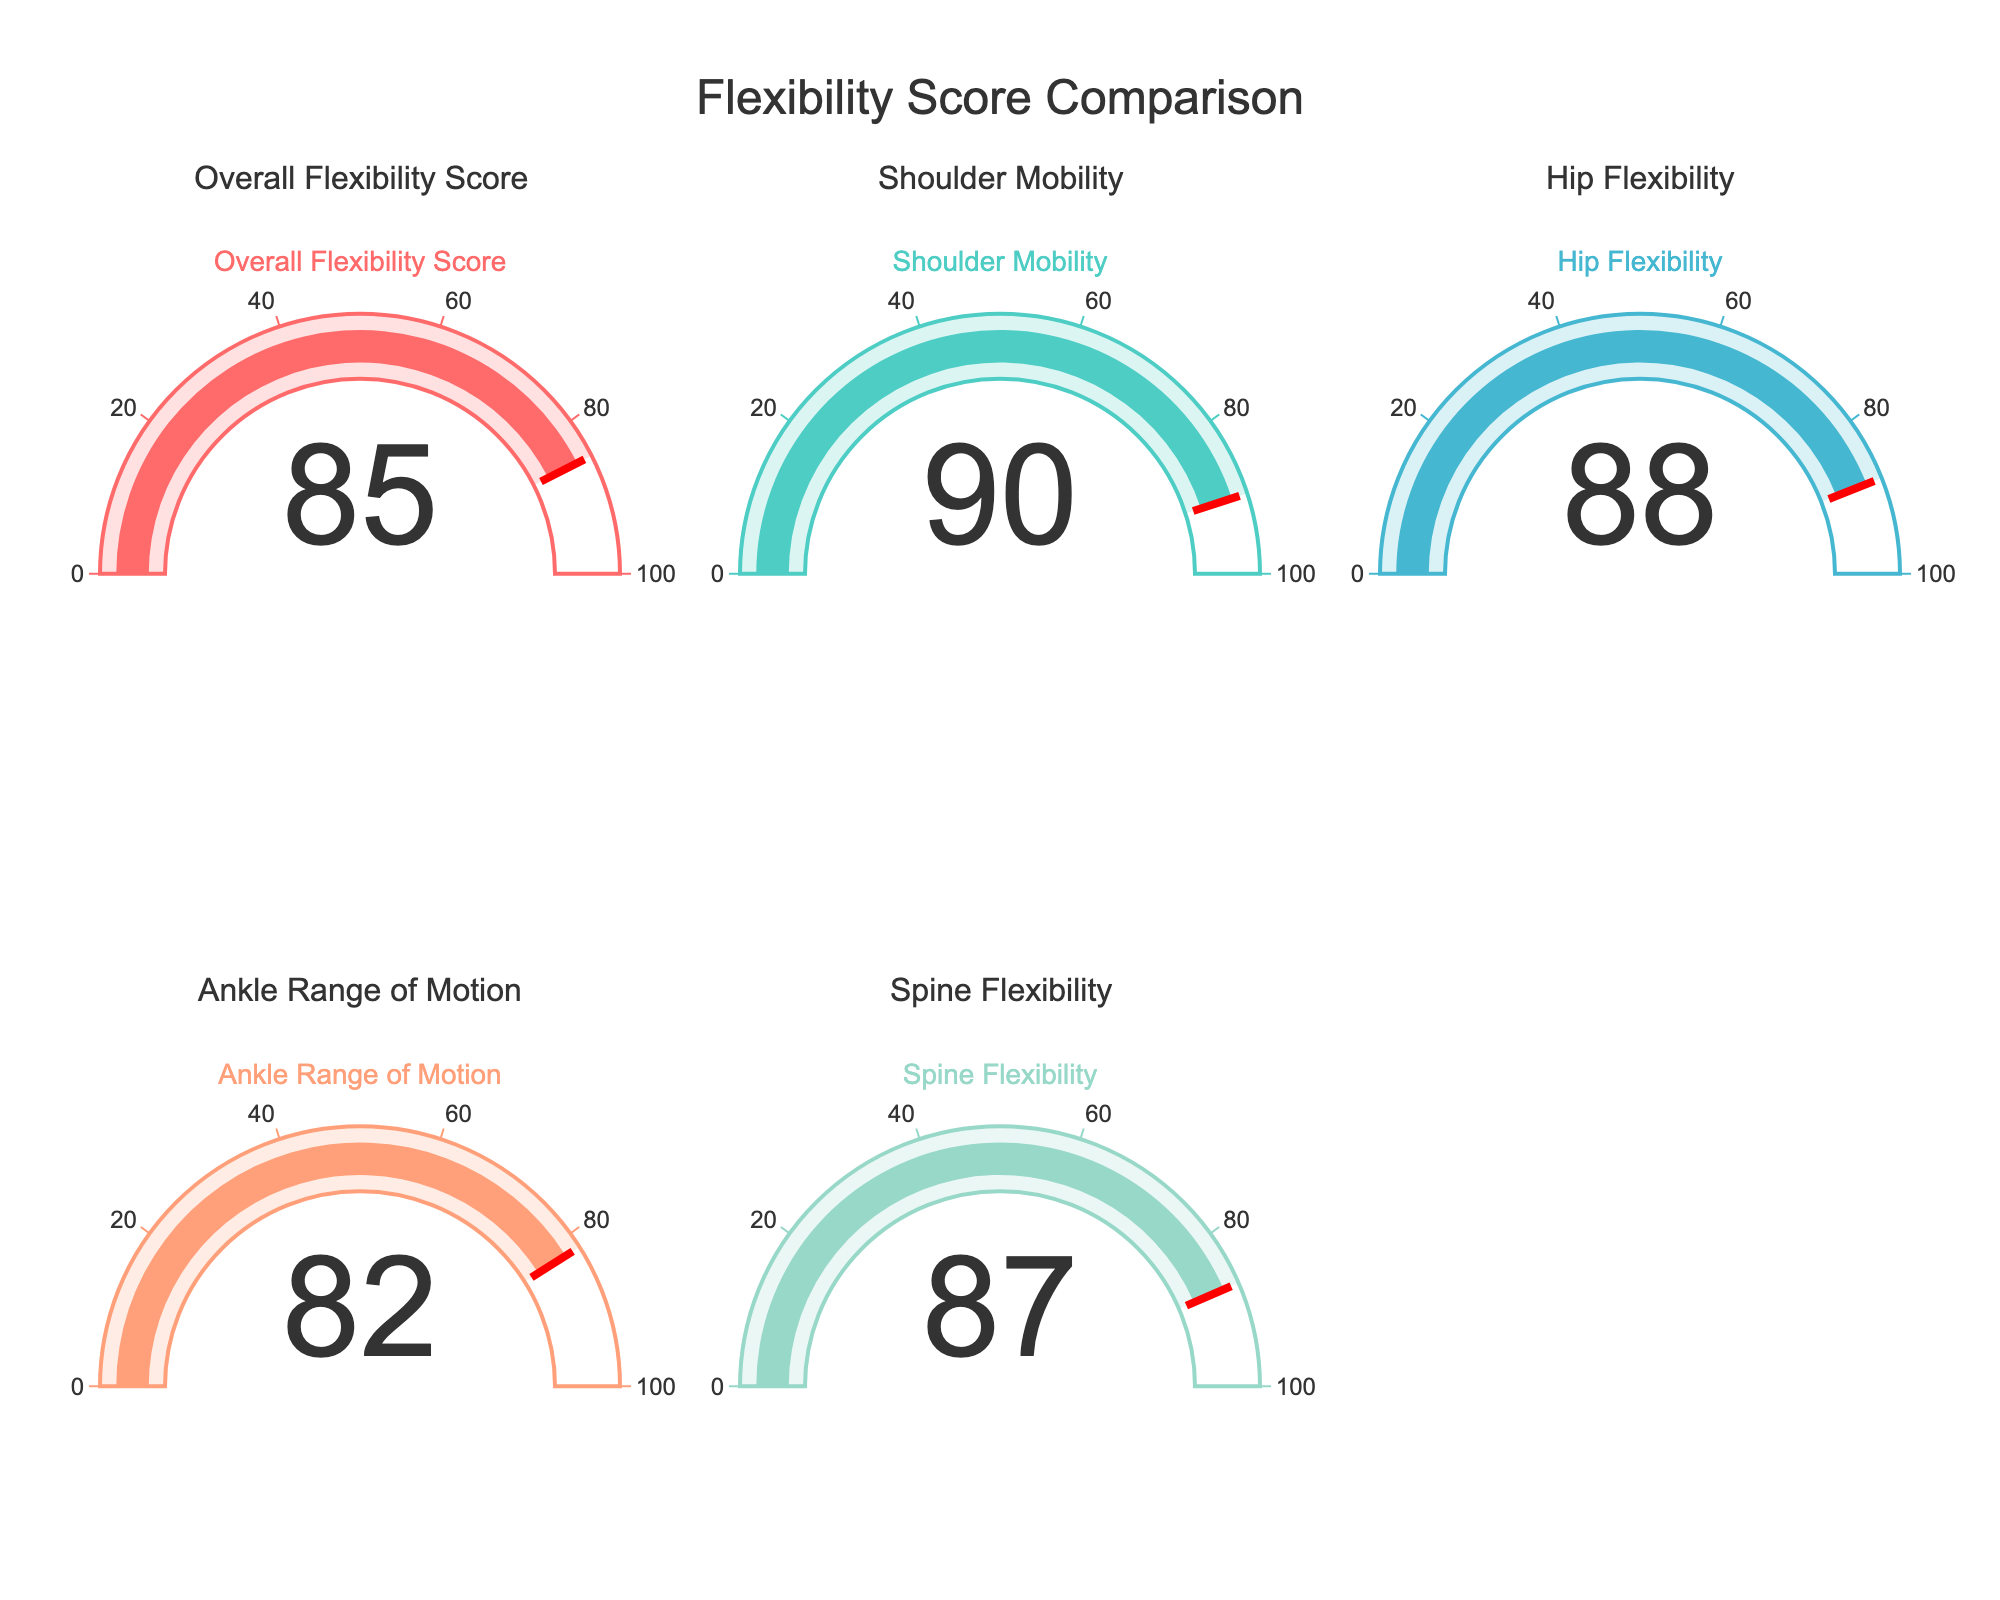What is the Overall Flexibility Score? The Indicator gauge for "Overall Flexibility Score" displays the numerical value directly, which is 85.
Answer: 85 What metric has the highest score? By looking at all the gauge charts, "Shoulder Mobility" has the highest value, which is 90.
Answer: Shoulder Mobility How much higher is the Shoulder Mobility score compared to the Ankle Range of Motion score? The Shoulder Mobility score is 90, and the Ankle Range of Motion score is 82. The difference is calculated as 90 - 82.
Answer: 8 Which metric has the lowest score, and what is that score? Among all the gauges, "Ankle Range of Motion" has the lowest score, which is 82.
Answer: Ankle Range of Motion, 82 What is the average of the overall scores displayed? Calculate the average of all the values: (85 + 90 + 88 + 82 + 87) / 5.
Answer: 86.4 Are any of the metrics below 85? Looking at the displayed values, "Ankle Range of Motion" is 82, which is below 85.
Answer: Yes How does Spine Flexibility compare to Hip Flexibility? The score for Spine Flexibility is 87, and the score for Hip Flexibility is 88. Therefore, Spine Flexibility is 1 point lower than Hip Flexibility.
Answer: 1 point lower What is the difference between the highest and lowest scores? The highest score is 90 (Shoulder Mobility) and the lowest score is 82 (Ankle Range of Motion). The difference is 90 - 82.
Answer: 8 What is the combined total of the Shoulder Mobility and Overall Flexibility Score metrics? Add the scores of Shoulder Mobility (90) and Overall Flexibility Score (85): 90 + 85.
Answer: 175 Which metric is closest to the average score (86.4)? By comparing all the scores to 86.4, "Spine Flexibility" with a score of 87 is the closest.
Answer: Spine Flexibility 